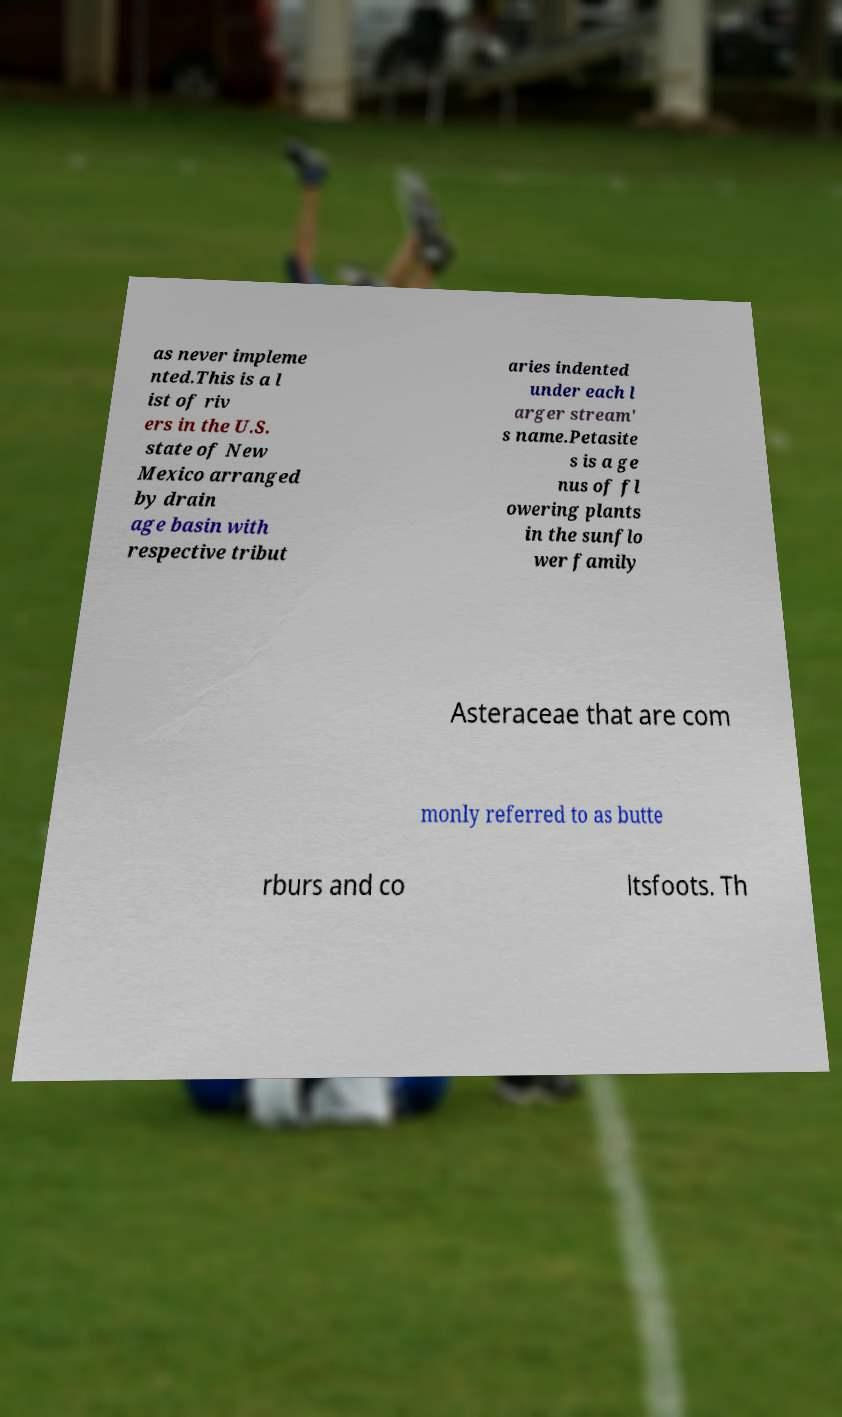Could you assist in decoding the text presented in this image and type it out clearly? as never impleme nted.This is a l ist of riv ers in the U.S. state of New Mexico arranged by drain age basin with respective tribut aries indented under each l arger stream' s name.Petasite s is a ge nus of fl owering plants in the sunflo wer family Asteraceae that are com monly referred to as butte rburs and co ltsfoots. Th 